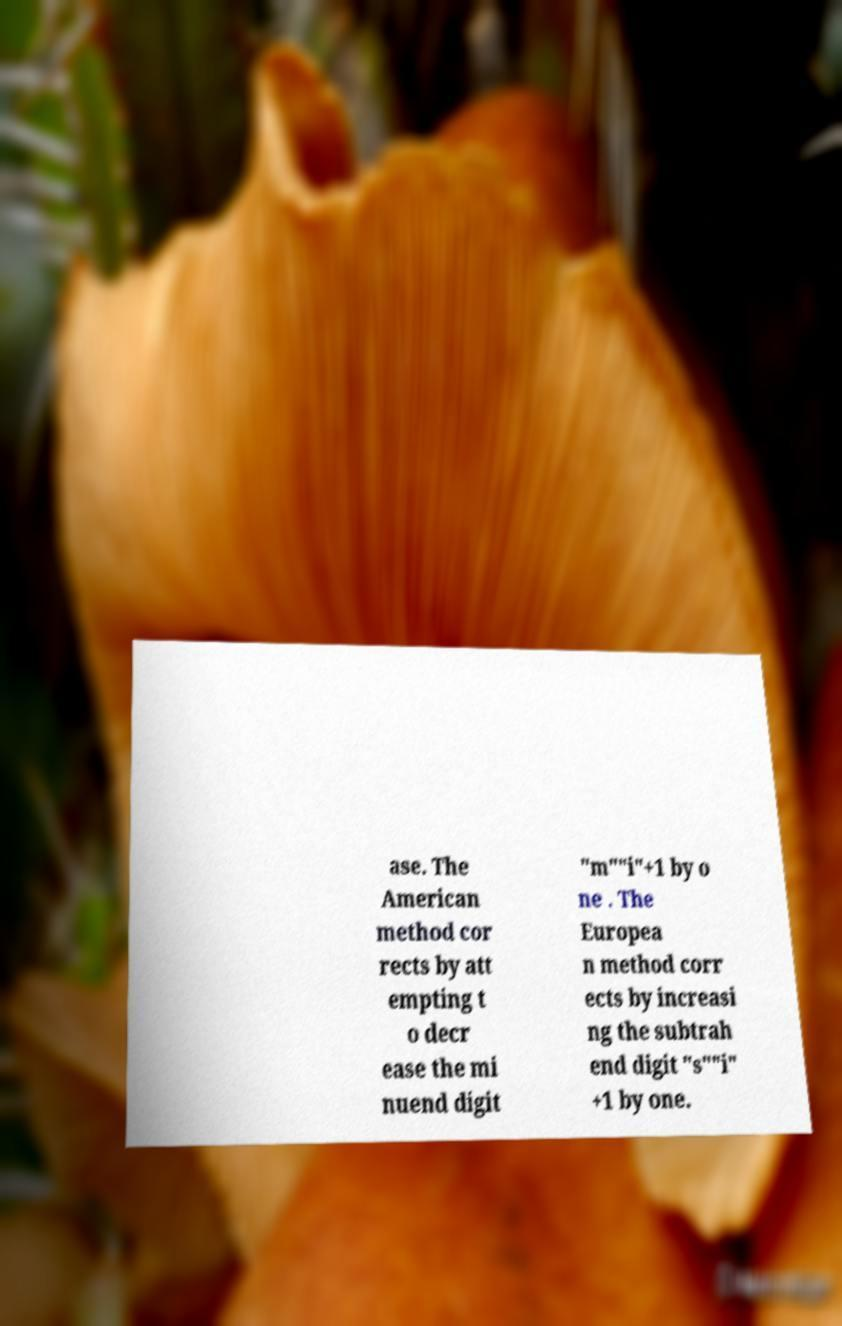For documentation purposes, I need the text within this image transcribed. Could you provide that? ase. The American method cor rects by att empting t o decr ease the mi nuend digit "m""i"+1 by o ne . The Europea n method corr ects by increasi ng the subtrah end digit "s""i" +1 by one. 